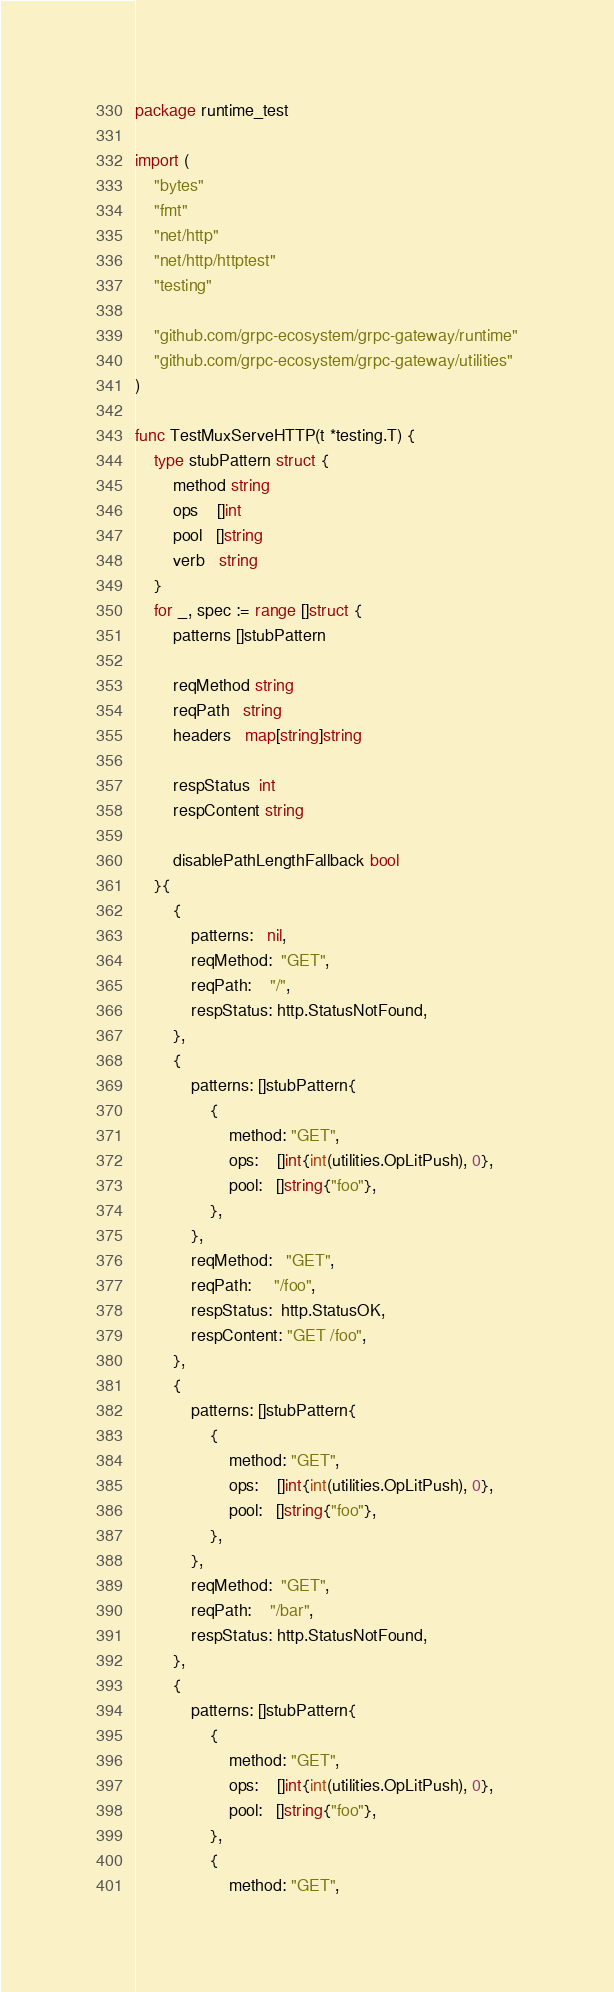<code> <loc_0><loc_0><loc_500><loc_500><_Go_>package runtime_test

import (
	"bytes"
	"fmt"
	"net/http"
	"net/http/httptest"
	"testing"

	"github.com/grpc-ecosystem/grpc-gateway/runtime"
	"github.com/grpc-ecosystem/grpc-gateway/utilities"
)

func TestMuxServeHTTP(t *testing.T) {
	type stubPattern struct {
		method string
		ops    []int
		pool   []string
		verb   string
	}
	for _, spec := range []struct {
		patterns []stubPattern

		reqMethod string
		reqPath   string
		headers   map[string]string

		respStatus  int
		respContent string

		disablePathLengthFallback bool
	}{
		{
			patterns:   nil,
			reqMethod:  "GET",
			reqPath:    "/",
			respStatus: http.StatusNotFound,
		},
		{
			patterns: []stubPattern{
				{
					method: "GET",
					ops:    []int{int(utilities.OpLitPush), 0},
					pool:   []string{"foo"},
				},
			},
			reqMethod:   "GET",
			reqPath:     "/foo",
			respStatus:  http.StatusOK,
			respContent: "GET /foo",
		},
		{
			patterns: []stubPattern{
				{
					method: "GET",
					ops:    []int{int(utilities.OpLitPush), 0},
					pool:   []string{"foo"},
				},
			},
			reqMethod:  "GET",
			reqPath:    "/bar",
			respStatus: http.StatusNotFound,
		},
		{
			patterns: []stubPattern{
				{
					method: "GET",
					ops:    []int{int(utilities.OpLitPush), 0},
					pool:   []string{"foo"},
				},
				{
					method: "GET",</code> 